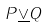<formula> <loc_0><loc_0><loc_500><loc_500>P \underline { \vee } Q</formula> 